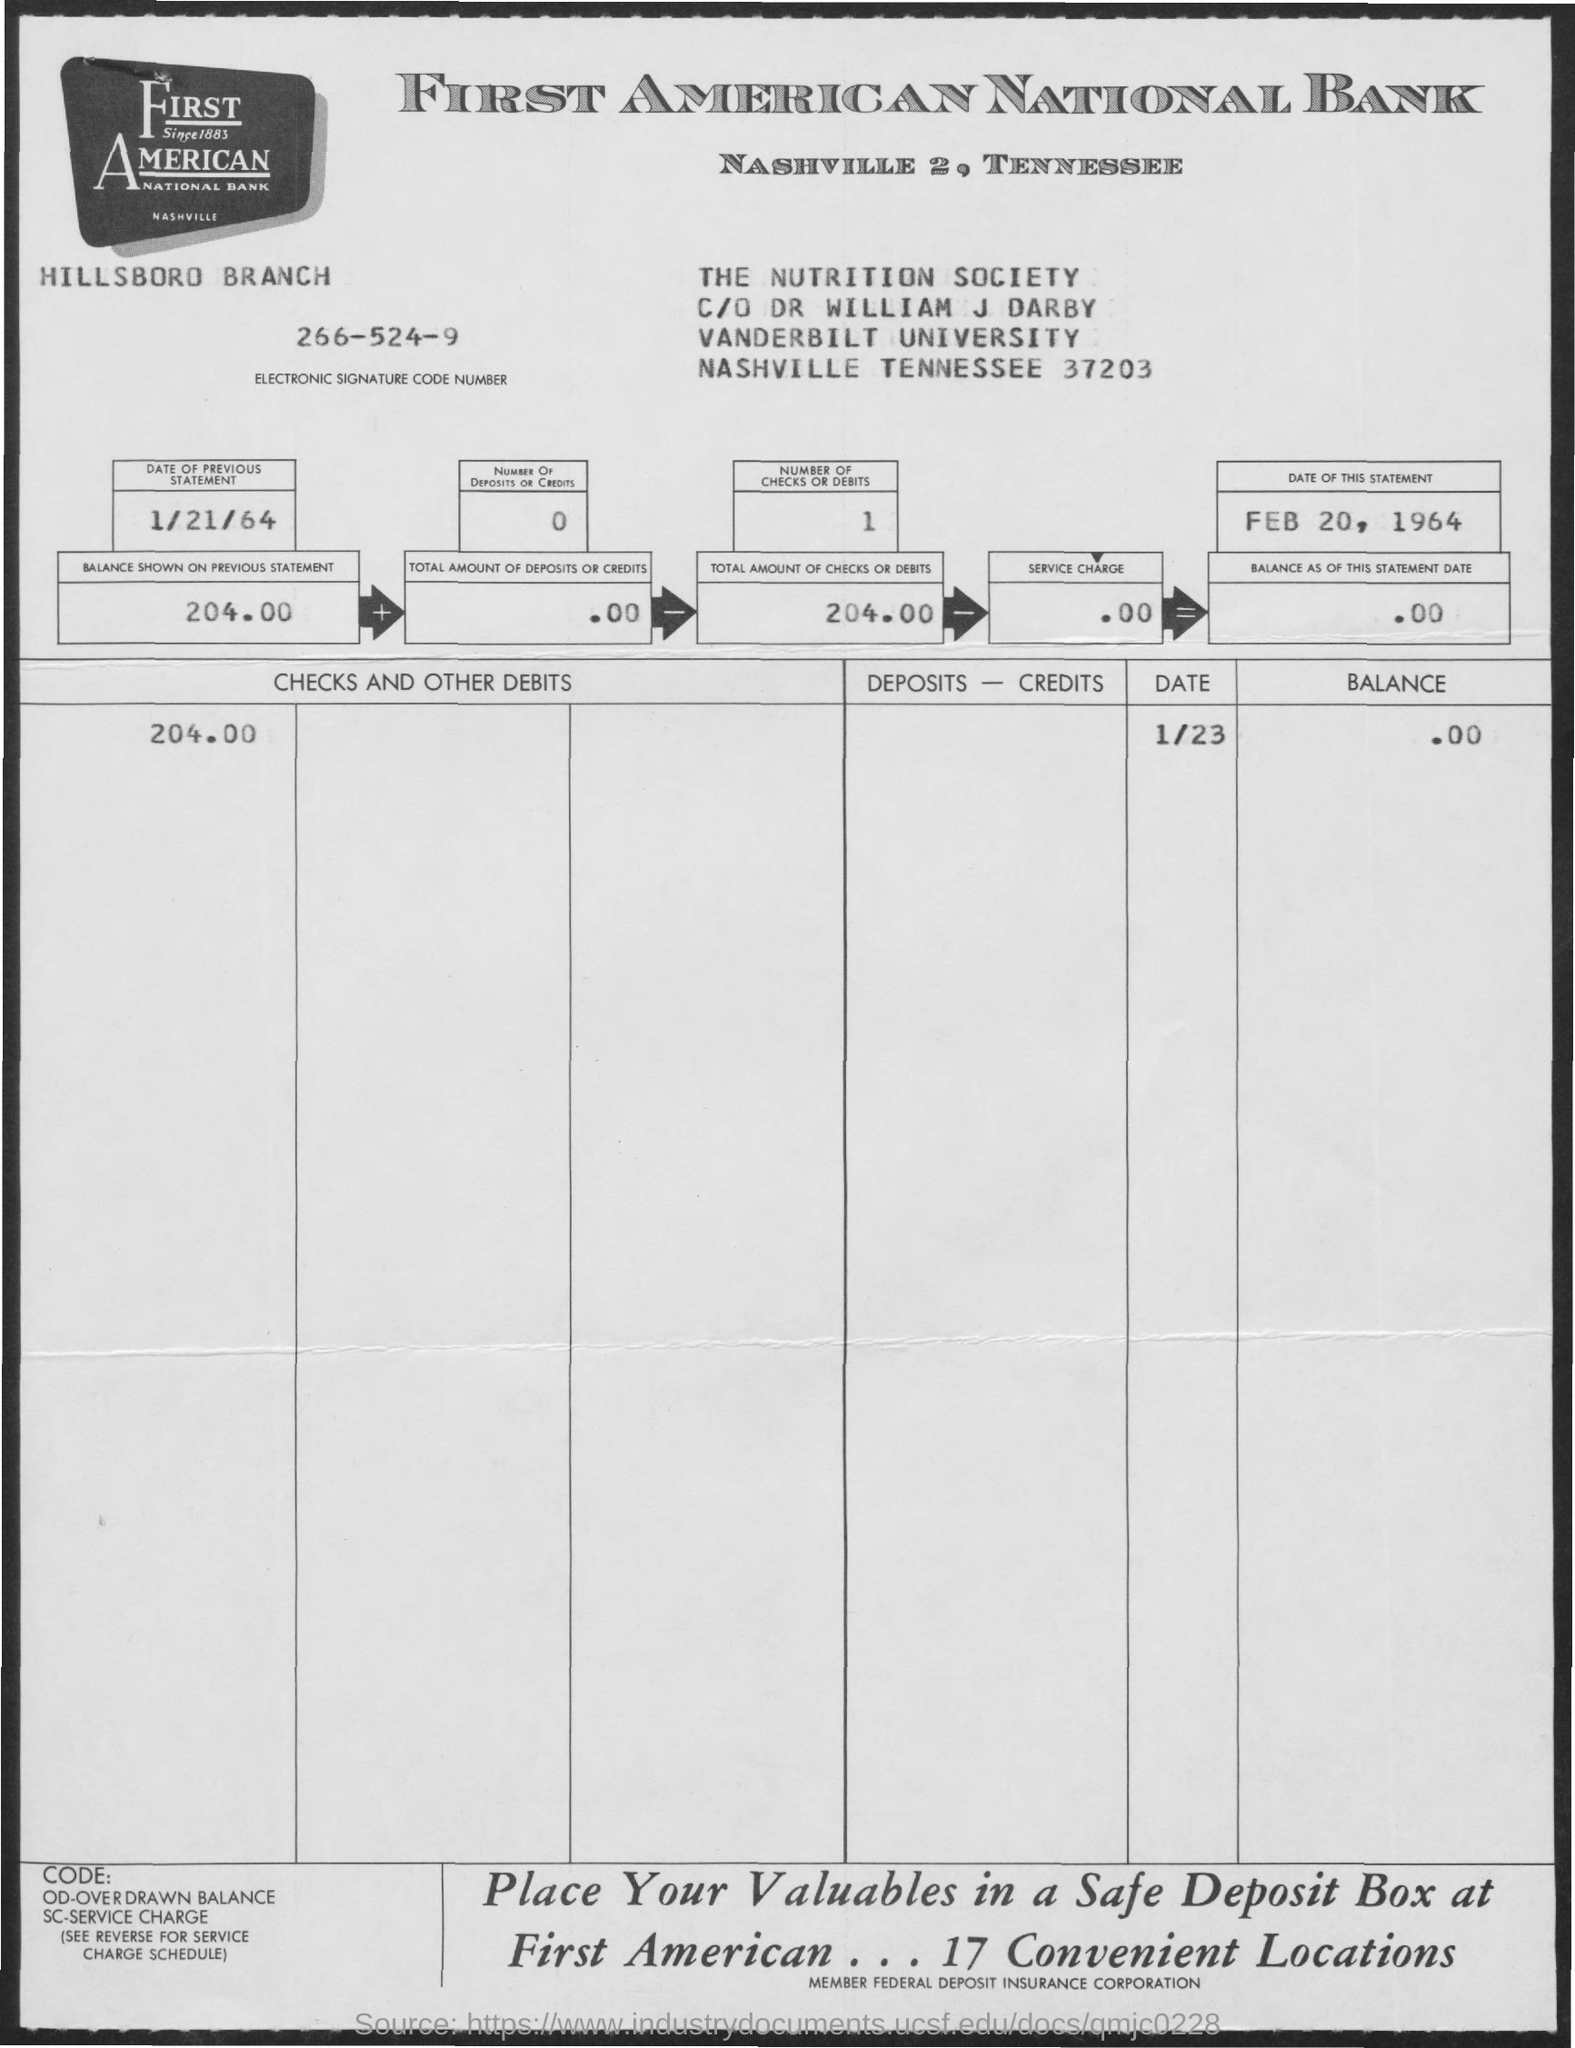What is the Electronic Signature Code Number given in the statement?
Your answer should be compact. 266-524-9. What is the date of previous statement?
Provide a short and direct response. 1/21/64. What is the date of this statement given?
Your response must be concise. Feb 20, 1964. What is the total amount of checks or debit mentioned in the statement?
Keep it short and to the point. 204.00. What is the balance shown on the previous statement?
Provide a short and direct response. 204.00. 